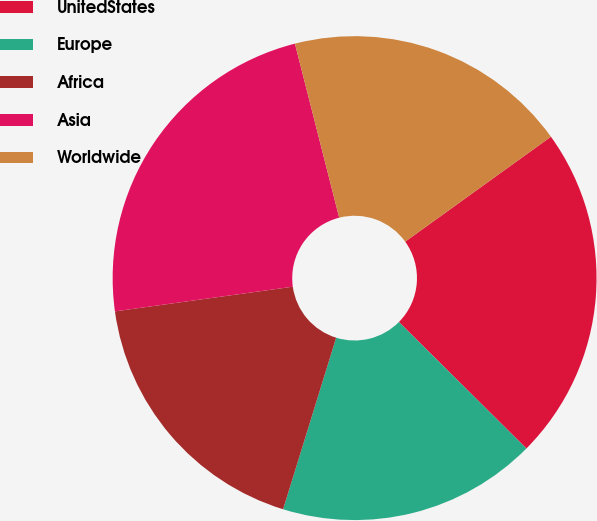Convert chart to OTSL. <chart><loc_0><loc_0><loc_500><loc_500><pie_chart><fcel>UnitedStates<fcel>Europe<fcel>Africa<fcel>Asia<fcel>Worldwide<nl><fcel>22.37%<fcel>17.34%<fcel>18.03%<fcel>23.23%<fcel>19.03%<nl></chart> 